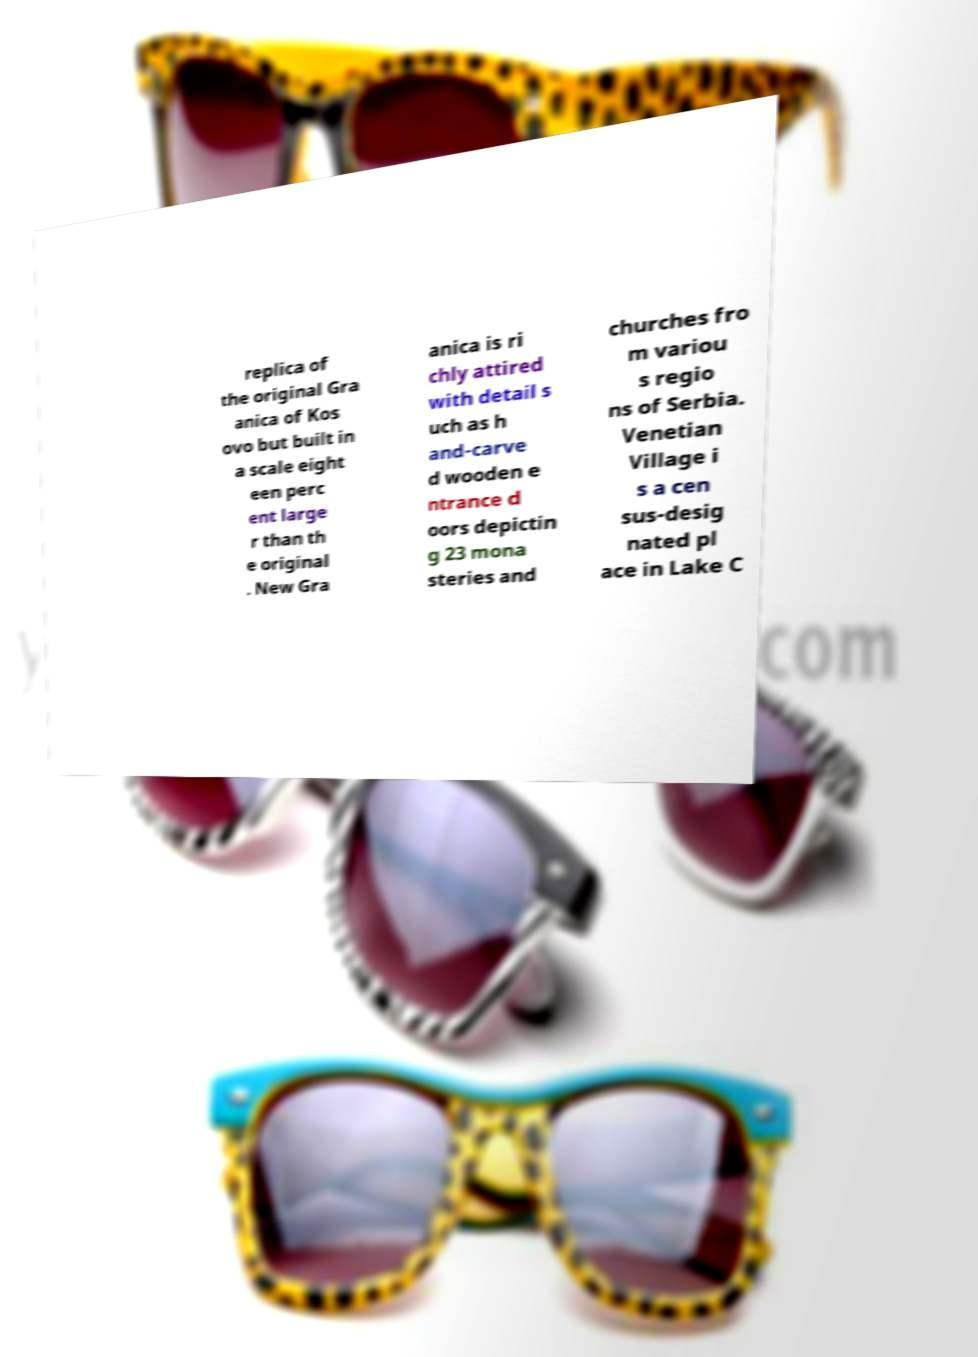I need the written content from this picture converted into text. Can you do that? replica of the original Gra anica of Kos ovo but built in a scale eight een perc ent large r than th e original . New Gra anica is ri chly attired with detail s uch as h and-carve d wooden e ntrance d oors depictin g 23 mona steries and churches fro m variou s regio ns of Serbia. Venetian Village i s a cen sus-desig nated pl ace in Lake C 